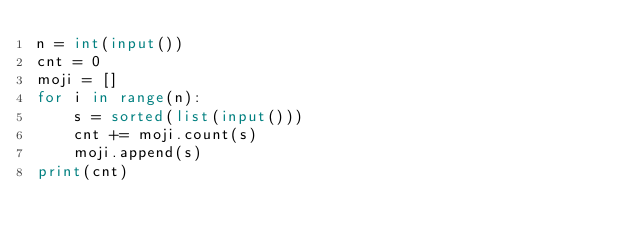<code> <loc_0><loc_0><loc_500><loc_500><_Python_>n = int(input())
cnt = 0
moji = []
for i in range(n):
    s = sorted(list(input()))
    cnt += moji.count(s)
    moji.append(s)
print(cnt)</code> 